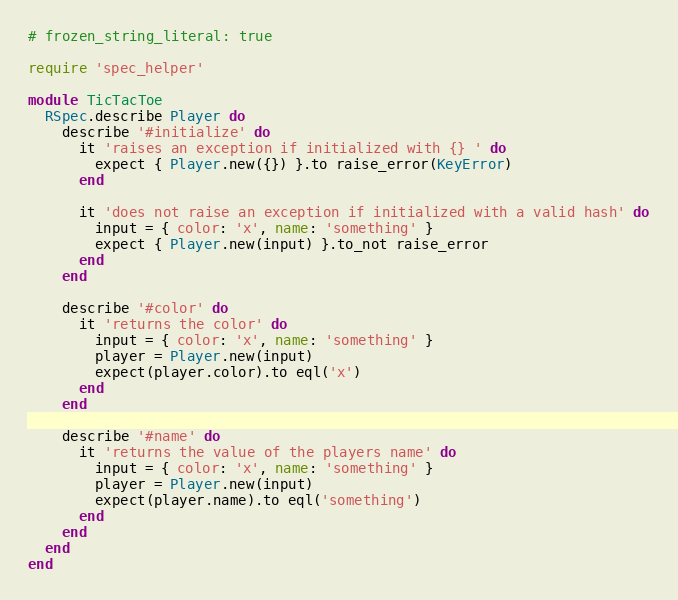Convert code to text. <code><loc_0><loc_0><loc_500><loc_500><_Ruby_># frozen_string_literal: true

require 'spec_helper'

module TicTacToe
  RSpec.describe Player do
    describe '#initialize' do
      it 'raises an exception if initialized with {} ' do
        expect { Player.new({}) }.to raise_error(KeyError)
      end

      it 'does not raise an exception if initialized with a valid hash' do
        input = { color: 'x', name: 'something' }
        expect { Player.new(input) }.to_not raise_error
      end
    end

    describe '#color' do
      it 'returns the color' do
        input = { color: 'x', name: 'something' }
        player = Player.new(input)
        expect(player.color).to eql('x')
      end
    end

    describe '#name' do
      it 'returns the value of the players name' do
        input = { color: 'x', name: 'something' }
        player = Player.new(input)
        expect(player.name).to eql('something')
      end
    end
  end
end
</code> 